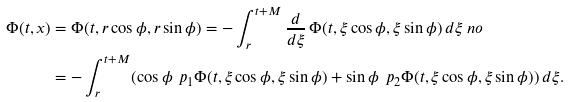Convert formula to latex. <formula><loc_0><loc_0><loc_500><loc_500>\Phi ( t , x ) & = \Phi ( t , r \cos \phi , r \sin \phi ) = - \int _ { r } ^ { t + M } \frac { d } { d \xi } \, \Phi ( t , \xi \cos \phi , \xi \sin \phi ) \, d \xi \ n o \\ & = - \int _ { r } ^ { t + M } ( \cos \phi \, \ p _ { 1 } \Phi ( t , \xi \cos \phi , \xi \sin \phi ) + \sin \phi \, \ p _ { 2 } \Phi ( t , \xi \cos \phi , \xi \sin \phi ) ) \, d \xi .</formula> 